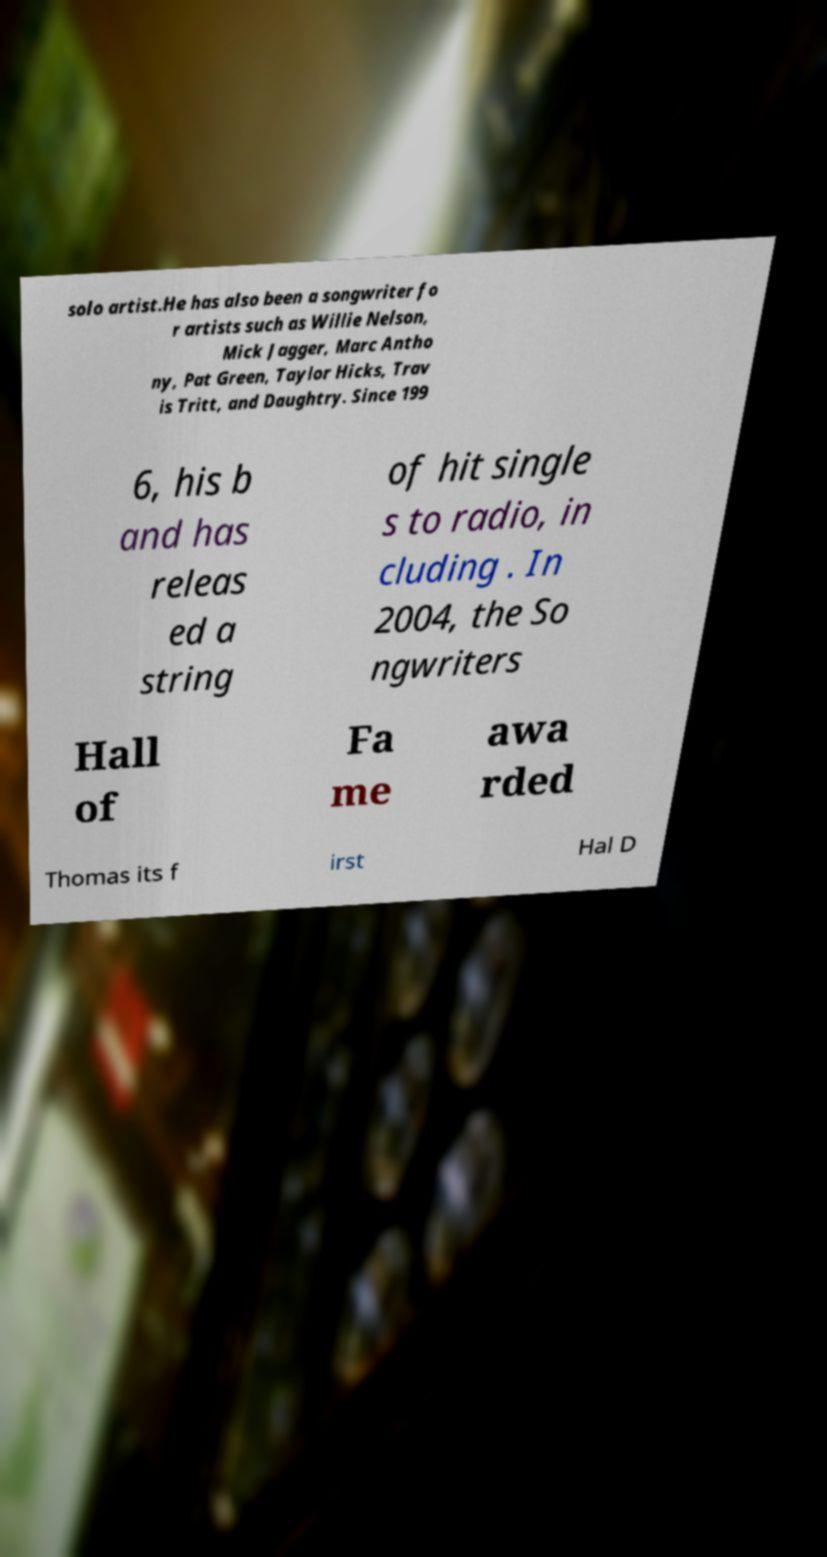For documentation purposes, I need the text within this image transcribed. Could you provide that? solo artist.He has also been a songwriter fo r artists such as Willie Nelson, Mick Jagger, Marc Antho ny, Pat Green, Taylor Hicks, Trav is Tritt, and Daughtry. Since 199 6, his b and has releas ed a string of hit single s to radio, in cluding . In 2004, the So ngwriters Hall of Fa me awa rded Thomas its f irst Hal D 